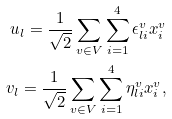<formula> <loc_0><loc_0><loc_500><loc_500>u _ { l } = \frac { 1 } { \sqrt { 2 } } \sum _ { v \in V } \sum _ { i = 1 } ^ { 4 } \epsilon ^ { v } _ { l i } x ^ { v } _ { i } \\ v _ { l } = \frac { 1 } { \sqrt { 2 } } \sum _ { v \in V } \sum _ { i = 1 } ^ { 4 } \eta ^ { v } _ { l i } x ^ { v } _ { i } ,</formula> 